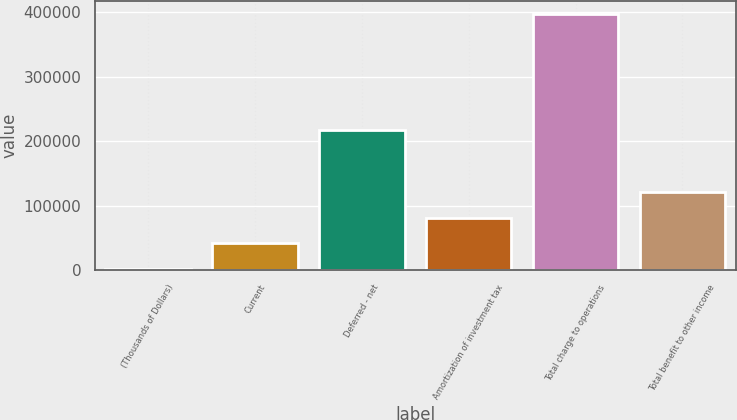<chart> <loc_0><loc_0><loc_500><loc_500><bar_chart><fcel>(Thousands of Dollars)<fcel>Current<fcel>Deferred - net<fcel>Amortization of investment tax<fcel>Total charge to operations<fcel>Total benefit to other income<nl><fcel>2002<fcel>41609<fcel>217192<fcel>81216<fcel>398072<fcel>120823<nl></chart> 